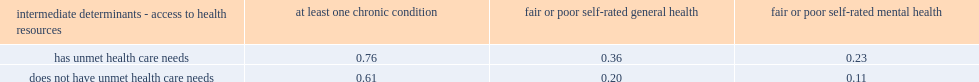What was the proportion of people with unmet health care needs reported to have at least one chronic condition? 0.76. What was the proportion of people without unmet health care needs reported to have at least one chronic condition? 0.61. Which type of people were more likely to have at least one chronic condition? Has unmet health care needs. What was the proportion of people with unmet health care needs reported to have fair or poor self-rated general health? 0.36. What was the proportion of people without unmet health care needs reported to have fair or poor self-rated general health? 0.2. Which type of people were more likely to have fair or poor self-rated general health? Has unmet health care needs. What was the proportion of people with unmet health care needs reported to have fair or poor self-rated mental health? 0.23. What was the proportion of people without unmet health care needs reported to have fair or poor self-rated mental health? 0.11. Which type of people were more likely to have fair or poor self-rated mental health? Has unmet health care needs. 